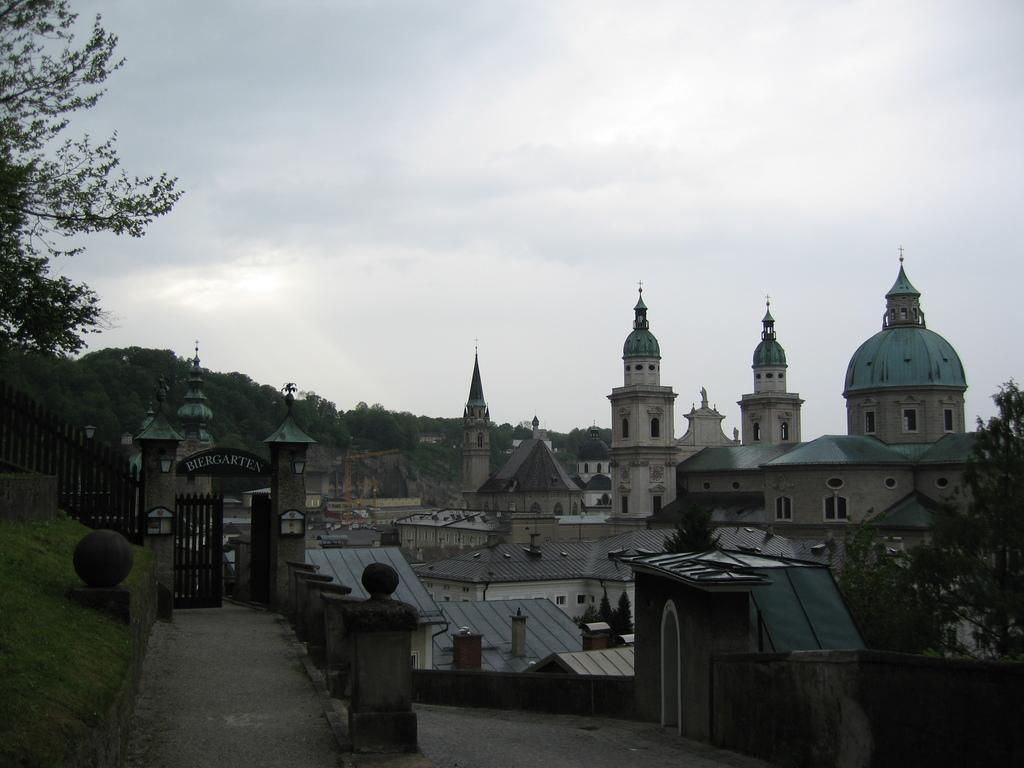What can be seen in the foreground of the image? In the foreground of the image, there is a path to walk, grass, a gate, a railing, and a tiny wall. What is the terrain like in the foreground of the image? The terrain in the foreground of the image consists of grass. What can be seen in the background of the image? In the background of the image, there are buildings, domes, trees, sky, and clouds. What type of sheet is used to cover the domes in the image? There is no sheet present in the image; the domes are visible in the background. What time of day is depicted in the image? The provided facts do not give any information about the time of day, so it cannot be determined from the image. 